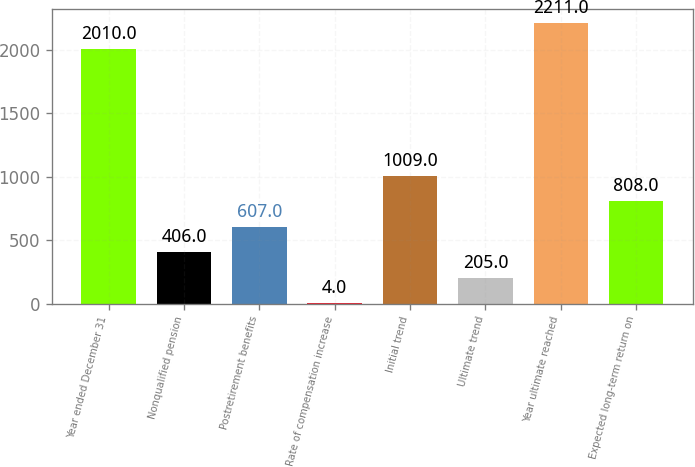<chart> <loc_0><loc_0><loc_500><loc_500><bar_chart><fcel>Year ended December 31<fcel>Nonqualified pension<fcel>Postretirement benefits<fcel>Rate of compensation increase<fcel>Initial trend<fcel>Ultimate trend<fcel>Year ultimate reached<fcel>Expected long-term return on<nl><fcel>2010<fcel>406<fcel>607<fcel>4<fcel>1009<fcel>205<fcel>2211<fcel>808<nl></chart> 